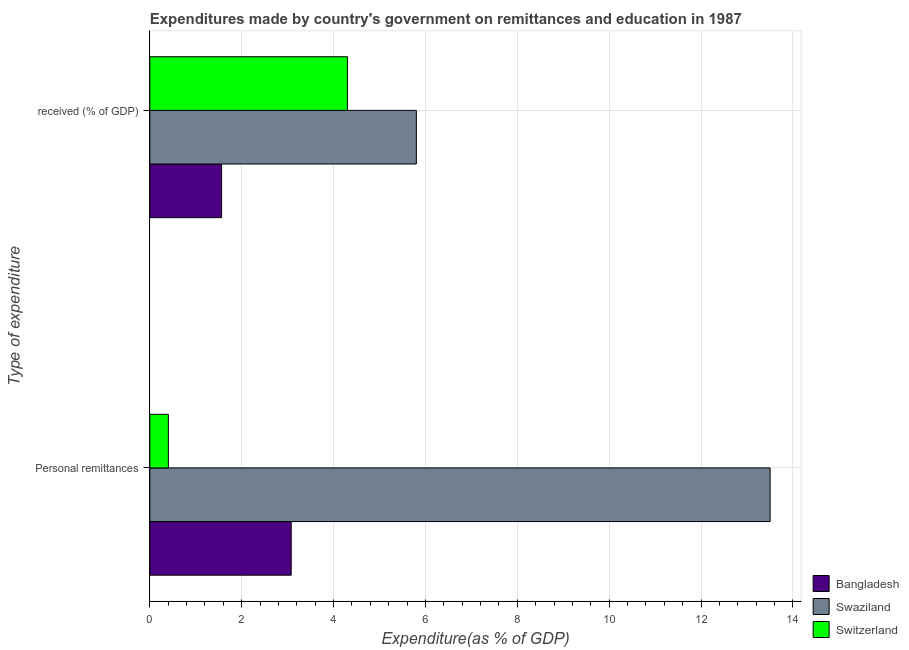How many groups of bars are there?
Your answer should be compact. 2. How many bars are there on the 1st tick from the bottom?
Keep it short and to the point. 3. What is the label of the 1st group of bars from the top?
Your answer should be compact.  received (% of GDP). What is the expenditure in personal remittances in Swaziland?
Your answer should be very brief. 13.5. Across all countries, what is the maximum expenditure in personal remittances?
Ensure brevity in your answer.  13.5. Across all countries, what is the minimum expenditure in education?
Give a very brief answer. 1.56. In which country was the expenditure in education maximum?
Give a very brief answer. Swaziland. In which country was the expenditure in personal remittances minimum?
Your response must be concise. Switzerland. What is the total expenditure in personal remittances in the graph?
Offer a very short reply. 16.99. What is the difference between the expenditure in personal remittances in Switzerland and that in Bangladesh?
Provide a short and direct response. -2.67. What is the difference between the expenditure in personal remittances in Bangladesh and the expenditure in education in Swaziland?
Offer a terse response. -2.72. What is the average expenditure in education per country?
Make the answer very short. 3.89. What is the difference between the expenditure in personal remittances and expenditure in education in Bangladesh?
Keep it short and to the point. 1.51. What is the ratio of the expenditure in personal remittances in Switzerland to that in Bangladesh?
Give a very brief answer. 0.13. Is the expenditure in personal remittances in Swaziland less than that in Switzerland?
Your answer should be compact. No. What does the 1st bar from the top in Personal remittances represents?
Keep it short and to the point. Switzerland. How many bars are there?
Give a very brief answer. 6. Are the values on the major ticks of X-axis written in scientific E-notation?
Your response must be concise. No. Does the graph contain any zero values?
Your answer should be very brief. No. Where does the legend appear in the graph?
Make the answer very short. Bottom right. How many legend labels are there?
Your answer should be very brief. 3. What is the title of the graph?
Provide a short and direct response. Expenditures made by country's government on remittances and education in 1987. Does "Lithuania" appear as one of the legend labels in the graph?
Provide a succinct answer. No. What is the label or title of the X-axis?
Offer a very short reply. Expenditure(as % of GDP). What is the label or title of the Y-axis?
Provide a short and direct response. Type of expenditure. What is the Expenditure(as % of GDP) of Bangladesh in Personal remittances?
Provide a succinct answer. 3.08. What is the Expenditure(as % of GDP) of Swaziland in Personal remittances?
Ensure brevity in your answer.  13.5. What is the Expenditure(as % of GDP) in Switzerland in Personal remittances?
Your answer should be very brief. 0.4. What is the Expenditure(as % of GDP) in Bangladesh in  received (% of GDP)?
Make the answer very short. 1.56. What is the Expenditure(as % of GDP) of Swaziland in  received (% of GDP)?
Provide a short and direct response. 5.8. What is the Expenditure(as % of GDP) of Switzerland in  received (% of GDP)?
Offer a terse response. 4.3. Across all Type of expenditure, what is the maximum Expenditure(as % of GDP) of Bangladesh?
Your answer should be compact. 3.08. Across all Type of expenditure, what is the maximum Expenditure(as % of GDP) in Swaziland?
Offer a terse response. 13.5. Across all Type of expenditure, what is the maximum Expenditure(as % of GDP) in Switzerland?
Make the answer very short. 4.3. Across all Type of expenditure, what is the minimum Expenditure(as % of GDP) of Bangladesh?
Keep it short and to the point. 1.56. Across all Type of expenditure, what is the minimum Expenditure(as % of GDP) in Swaziland?
Your answer should be compact. 5.8. Across all Type of expenditure, what is the minimum Expenditure(as % of GDP) in Switzerland?
Your answer should be compact. 0.4. What is the total Expenditure(as % of GDP) of Bangladesh in the graph?
Make the answer very short. 4.64. What is the total Expenditure(as % of GDP) of Swaziland in the graph?
Offer a terse response. 19.31. What is the total Expenditure(as % of GDP) of Switzerland in the graph?
Make the answer very short. 4.71. What is the difference between the Expenditure(as % of GDP) in Bangladesh in Personal remittances and that in  received (% of GDP)?
Make the answer very short. 1.51. What is the difference between the Expenditure(as % of GDP) in Swaziland in Personal remittances and that in  received (% of GDP)?
Your answer should be compact. 7.7. What is the difference between the Expenditure(as % of GDP) in Switzerland in Personal remittances and that in  received (% of GDP)?
Keep it short and to the point. -3.9. What is the difference between the Expenditure(as % of GDP) of Bangladesh in Personal remittances and the Expenditure(as % of GDP) of Swaziland in  received (% of GDP)?
Give a very brief answer. -2.72. What is the difference between the Expenditure(as % of GDP) in Bangladesh in Personal remittances and the Expenditure(as % of GDP) in Switzerland in  received (% of GDP)?
Your answer should be compact. -1.22. What is the difference between the Expenditure(as % of GDP) in Swaziland in Personal remittances and the Expenditure(as % of GDP) in Switzerland in  received (% of GDP)?
Your answer should be compact. 9.2. What is the average Expenditure(as % of GDP) of Bangladesh per Type of expenditure?
Give a very brief answer. 2.32. What is the average Expenditure(as % of GDP) in Swaziland per Type of expenditure?
Provide a short and direct response. 9.65. What is the average Expenditure(as % of GDP) in Switzerland per Type of expenditure?
Offer a very short reply. 2.35. What is the difference between the Expenditure(as % of GDP) of Bangladesh and Expenditure(as % of GDP) of Swaziland in Personal remittances?
Make the answer very short. -10.43. What is the difference between the Expenditure(as % of GDP) of Bangladesh and Expenditure(as % of GDP) of Switzerland in Personal remittances?
Your answer should be very brief. 2.67. What is the difference between the Expenditure(as % of GDP) of Swaziland and Expenditure(as % of GDP) of Switzerland in Personal remittances?
Keep it short and to the point. 13.1. What is the difference between the Expenditure(as % of GDP) in Bangladesh and Expenditure(as % of GDP) in Swaziland in  received (% of GDP)?
Your answer should be compact. -4.24. What is the difference between the Expenditure(as % of GDP) in Bangladesh and Expenditure(as % of GDP) in Switzerland in  received (% of GDP)?
Ensure brevity in your answer.  -2.74. What is the difference between the Expenditure(as % of GDP) in Swaziland and Expenditure(as % of GDP) in Switzerland in  received (% of GDP)?
Your answer should be compact. 1.5. What is the ratio of the Expenditure(as % of GDP) in Bangladesh in Personal remittances to that in  received (% of GDP)?
Your response must be concise. 1.97. What is the ratio of the Expenditure(as % of GDP) of Swaziland in Personal remittances to that in  received (% of GDP)?
Offer a terse response. 2.33. What is the ratio of the Expenditure(as % of GDP) of Switzerland in Personal remittances to that in  received (% of GDP)?
Provide a succinct answer. 0.09. What is the difference between the highest and the second highest Expenditure(as % of GDP) in Bangladesh?
Your answer should be very brief. 1.51. What is the difference between the highest and the second highest Expenditure(as % of GDP) in Swaziland?
Provide a short and direct response. 7.7. What is the difference between the highest and the second highest Expenditure(as % of GDP) of Switzerland?
Ensure brevity in your answer.  3.9. What is the difference between the highest and the lowest Expenditure(as % of GDP) in Bangladesh?
Give a very brief answer. 1.51. What is the difference between the highest and the lowest Expenditure(as % of GDP) in Swaziland?
Keep it short and to the point. 7.7. What is the difference between the highest and the lowest Expenditure(as % of GDP) in Switzerland?
Make the answer very short. 3.9. 